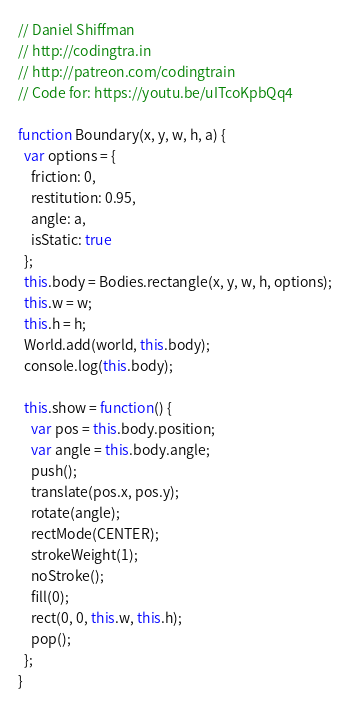Convert code to text. <code><loc_0><loc_0><loc_500><loc_500><_JavaScript_>// Daniel Shiffman
// http://codingtra.in
// http://patreon.com/codingtrain
// Code for: https://youtu.be/uITcoKpbQq4

function Boundary(x, y, w, h, a) {
  var options = {
    friction: 0,
    restitution: 0.95,
    angle: a,
    isStatic: true
  };
  this.body = Bodies.rectangle(x, y, w, h, options);
  this.w = w;
  this.h = h;
  World.add(world, this.body);
  console.log(this.body);

  this.show = function() {
    var pos = this.body.position;
    var angle = this.body.angle;
    push();
    translate(pos.x, pos.y);
    rotate(angle);
    rectMode(CENTER);
    strokeWeight(1);
    noStroke();
    fill(0);
    rect(0, 0, this.w, this.h);
    pop();
  };
}
</code> 